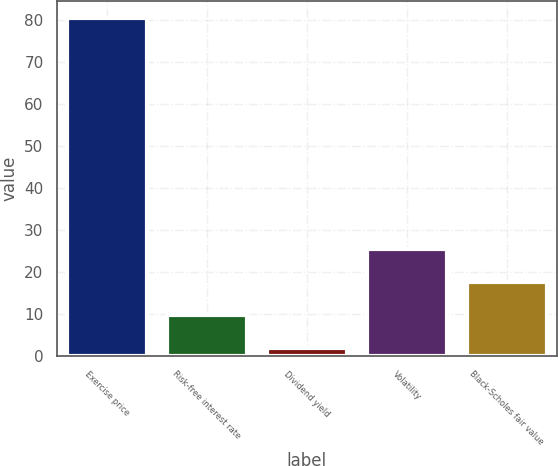Convert chart to OTSL. <chart><loc_0><loc_0><loc_500><loc_500><bar_chart><fcel>Exercise price<fcel>Risk-free interest rate<fcel>Dividend yield<fcel>Volatility<fcel>Black-Scholes fair value<nl><fcel>80.44<fcel>9.84<fcel>2<fcel>25.52<fcel>17.68<nl></chart> 